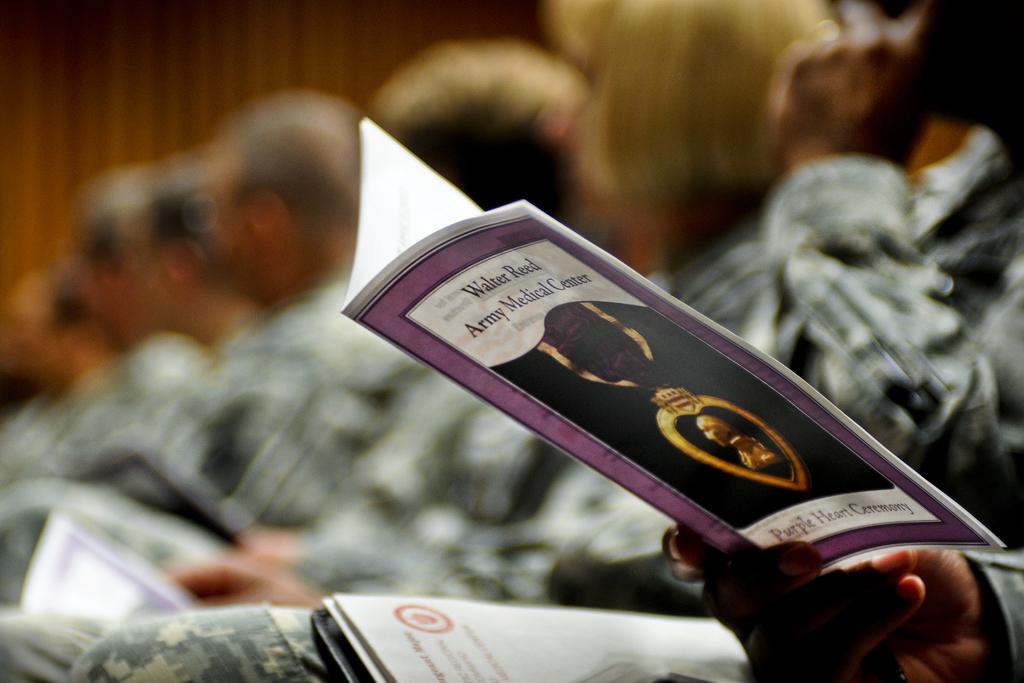What type of ceremony is mentioned on the brochure?
Offer a very short reply. Purple heart. 